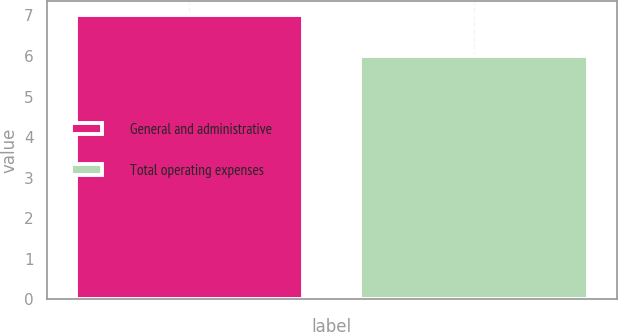Convert chart. <chart><loc_0><loc_0><loc_500><loc_500><bar_chart><fcel>General and administrative<fcel>Total operating expenses<nl><fcel>7<fcel>6<nl></chart> 